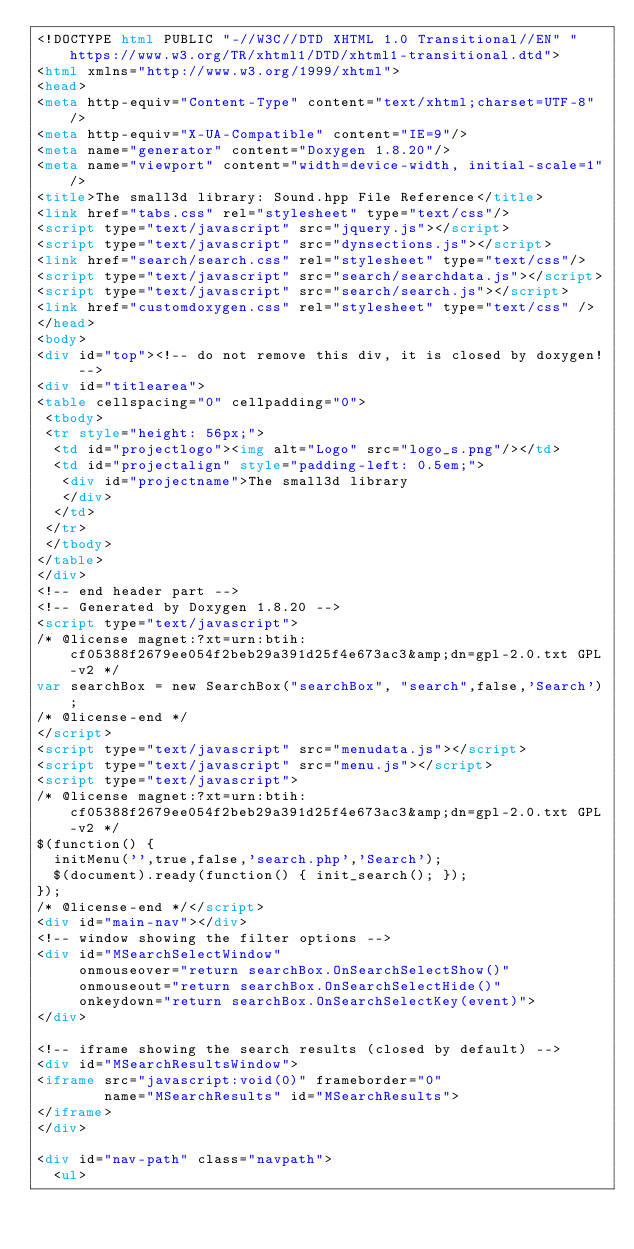Convert code to text. <code><loc_0><loc_0><loc_500><loc_500><_HTML_><!DOCTYPE html PUBLIC "-//W3C//DTD XHTML 1.0 Transitional//EN" "https://www.w3.org/TR/xhtml1/DTD/xhtml1-transitional.dtd">
<html xmlns="http://www.w3.org/1999/xhtml">
<head>
<meta http-equiv="Content-Type" content="text/xhtml;charset=UTF-8"/>
<meta http-equiv="X-UA-Compatible" content="IE=9"/>
<meta name="generator" content="Doxygen 1.8.20"/>
<meta name="viewport" content="width=device-width, initial-scale=1"/>
<title>The small3d library: Sound.hpp File Reference</title>
<link href="tabs.css" rel="stylesheet" type="text/css"/>
<script type="text/javascript" src="jquery.js"></script>
<script type="text/javascript" src="dynsections.js"></script>
<link href="search/search.css" rel="stylesheet" type="text/css"/>
<script type="text/javascript" src="search/searchdata.js"></script>
<script type="text/javascript" src="search/search.js"></script>
<link href="customdoxygen.css" rel="stylesheet" type="text/css" />
</head>
<body>
<div id="top"><!-- do not remove this div, it is closed by doxygen! -->
<div id="titlearea">
<table cellspacing="0" cellpadding="0">
 <tbody>
 <tr style="height: 56px;">
  <td id="projectlogo"><img alt="Logo" src="logo_s.png"/></td>
  <td id="projectalign" style="padding-left: 0.5em;">
   <div id="projectname">The small3d library
   </div>
  </td>
 </tr>
 </tbody>
</table>
</div>
<!-- end header part -->
<!-- Generated by Doxygen 1.8.20 -->
<script type="text/javascript">
/* @license magnet:?xt=urn:btih:cf05388f2679ee054f2beb29a391d25f4e673ac3&amp;dn=gpl-2.0.txt GPL-v2 */
var searchBox = new SearchBox("searchBox", "search",false,'Search');
/* @license-end */
</script>
<script type="text/javascript" src="menudata.js"></script>
<script type="text/javascript" src="menu.js"></script>
<script type="text/javascript">
/* @license magnet:?xt=urn:btih:cf05388f2679ee054f2beb29a391d25f4e673ac3&amp;dn=gpl-2.0.txt GPL-v2 */
$(function() {
  initMenu('',true,false,'search.php','Search');
  $(document).ready(function() { init_search(); });
});
/* @license-end */</script>
<div id="main-nav"></div>
<!-- window showing the filter options -->
<div id="MSearchSelectWindow"
     onmouseover="return searchBox.OnSearchSelectShow()"
     onmouseout="return searchBox.OnSearchSelectHide()"
     onkeydown="return searchBox.OnSearchSelectKey(event)">
</div>

<!-- iframe showing the search results (closed by default) -->
<div id="MSearchResultsWindow">
<iframe src="javascript:void(0)" frameborder="0" 
        name="MSearchResults" id="MSearchResults">
</iframe>
</div>

<div id="nav-path" class="navpath">
  <ul></code> 